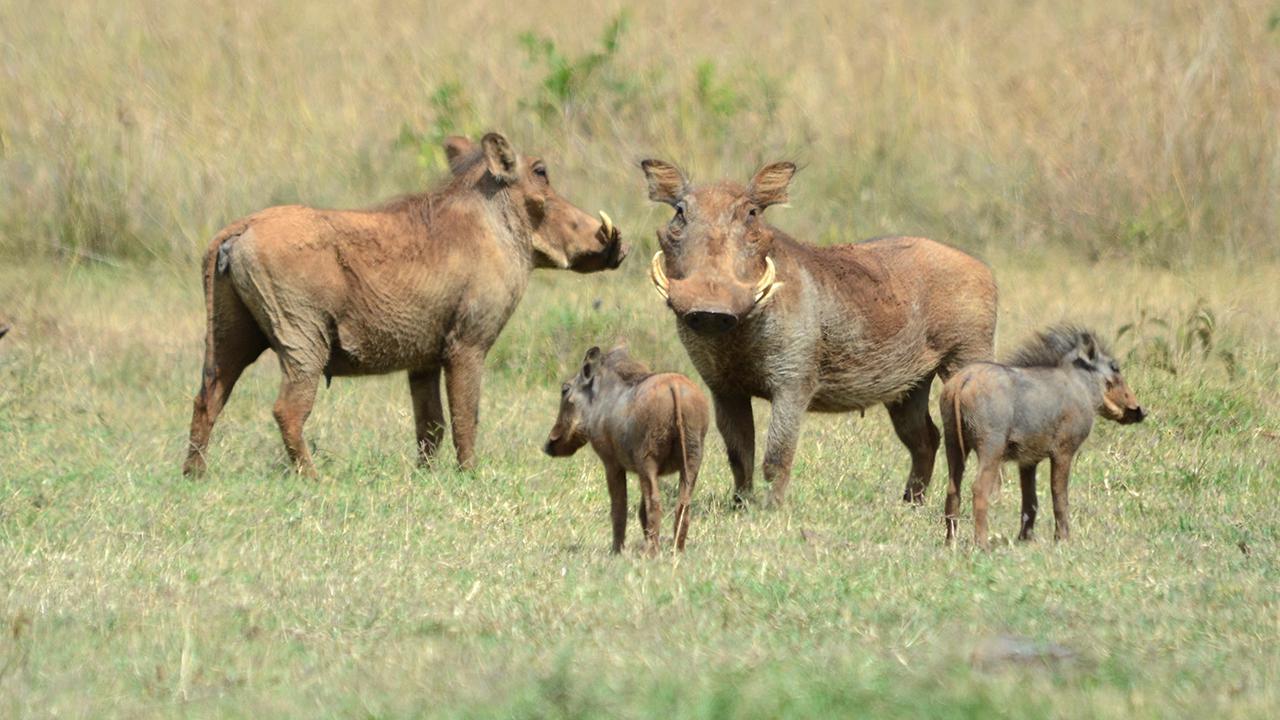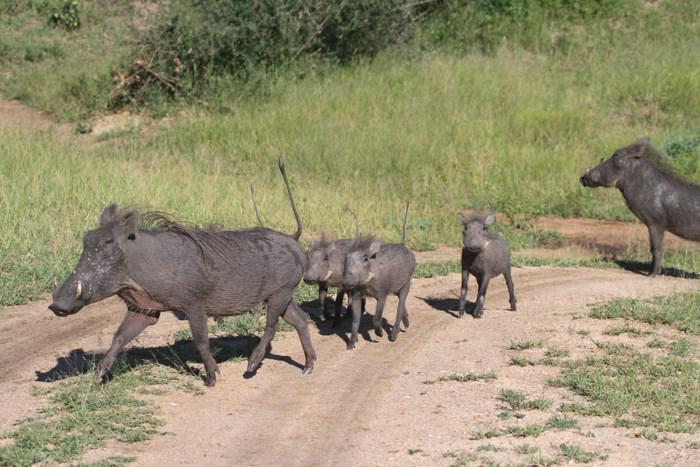The first image is the image on the left, the second image is the image on the right. For the images displayed, is the sentence "There is a group of warthogs by the water." factually correct? Answer yes or no. No. The first image is the image on the left, the second image is the image on the right. Assess this claim about the two images: "An image shows a water source for warthogs.". Correct or not? Answer yes or no. No. 